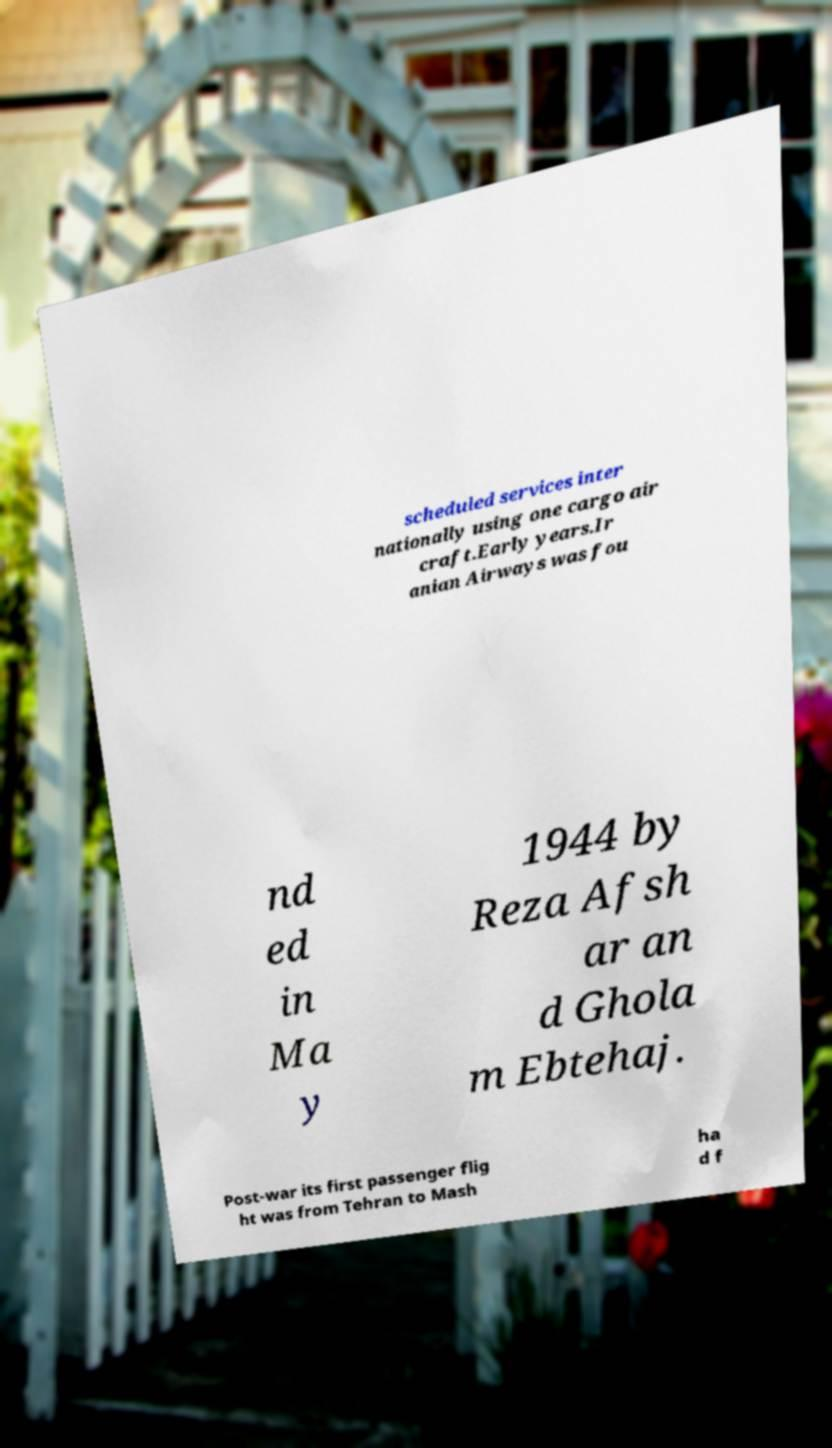Please identify and transcribe the text found in this image. scheduled services inter nationally using one cargo air craft.Early years.Ir anian Airways was fou nd ed in Ma y 1944 by Reza Afsh ar an d Ghola m Ebtehaj. Post-war its first passenger flig ht was from Tehran to Mash ha d f 